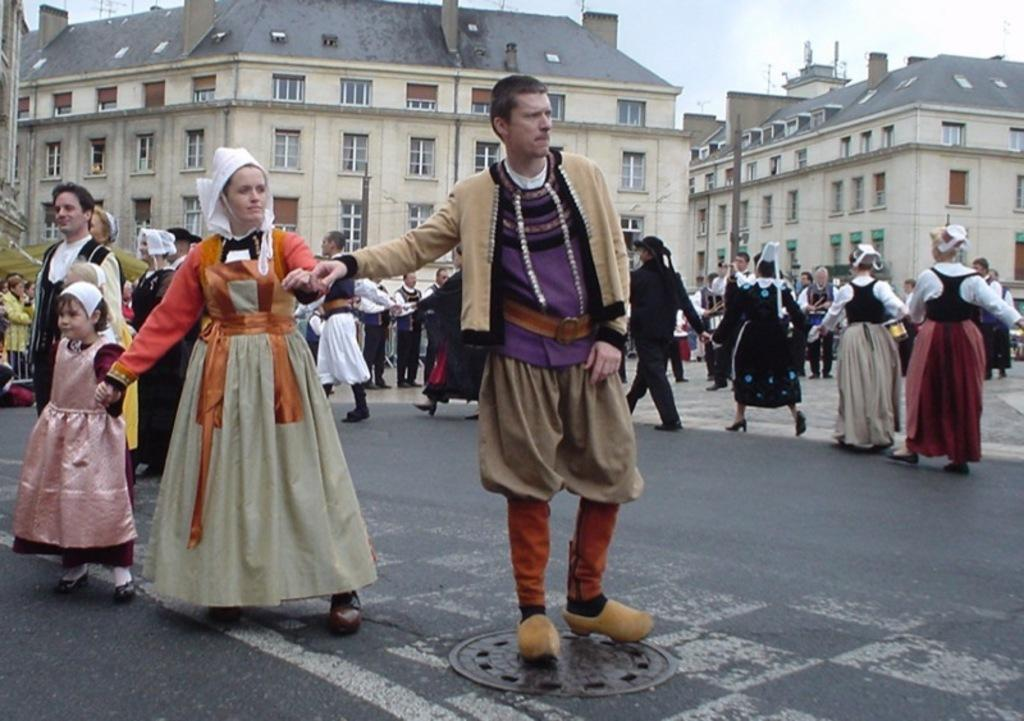How many people are present in the image? There are many people in the image. What are some of the people doing in the image? Some of the people are walking, and some are standing. What can be seen in the background of the image? There are buildings and the sky visible in the background of the image. What type of body is visible in the image? There is no specific body present in the image; it features a group of people. What is the purpose of the station in the image? There is no station present in the image. 